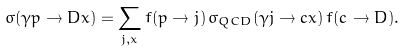Convert formula to latex. <formula><loc_0><loc_0><loc_500><loc_500>\sigma ( \gamma p \to D x ) = \sum _ { j , x } f ( p \to j ) \, \sigma _ { Q C D } ( \gamma j \to c x ) \, f ( c \to D ) .</formula> 